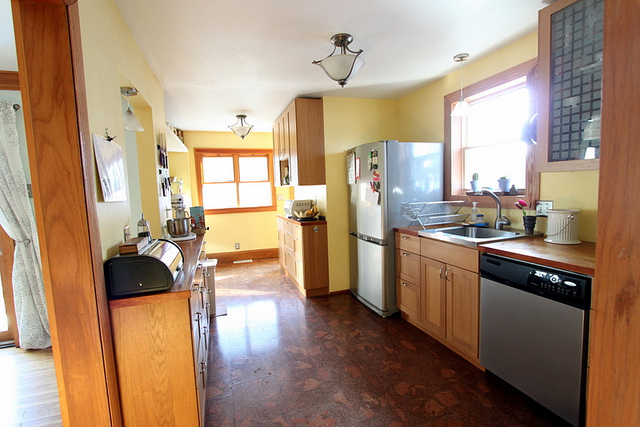What can you tell about the seasonal setting outside from this picture? The bright sunlight and the view from the window suggest it might be a sunny day, likely in spring or summer, contributing to the warm and welcoming atmosphere of the kitchen. 